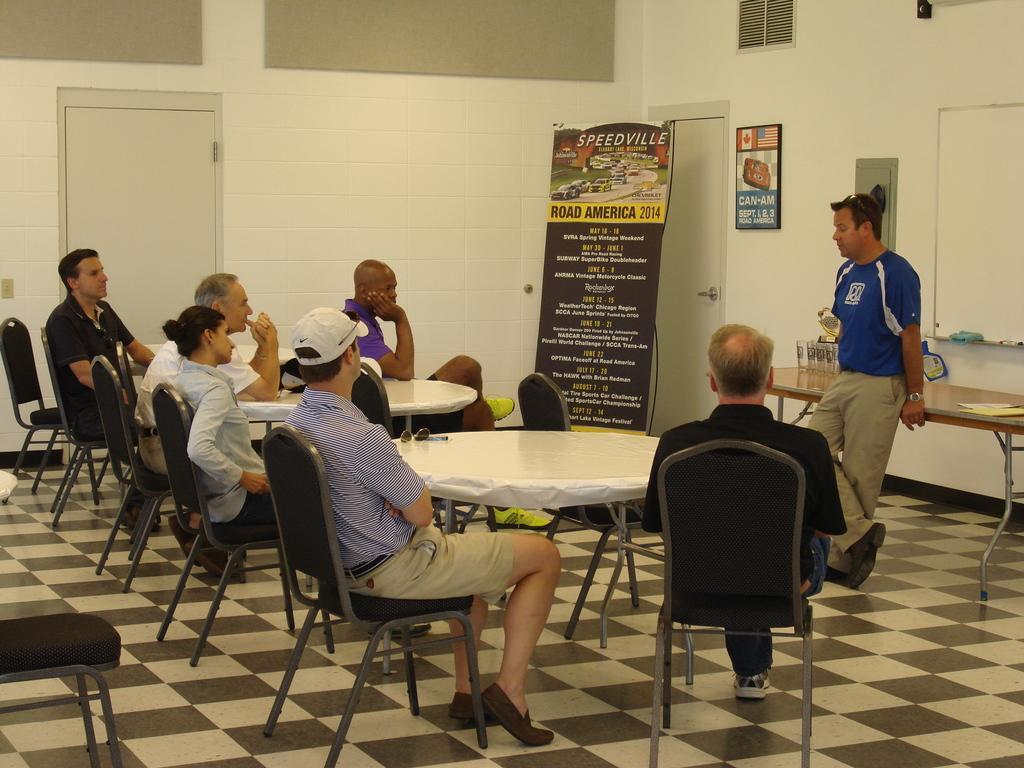Can you describe this image briefly? people are sitting on the chair. tables are present in front of them. at the right a person is standing. at the back there is a banner on which road america 2014 is written. 